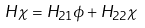Convert formula to latex. <formula><loc_0><loc_0><loc_500><loc_500>H \chi = H _ { 2 1 } \phi + H _ { 2 2 } \chi</formula> 